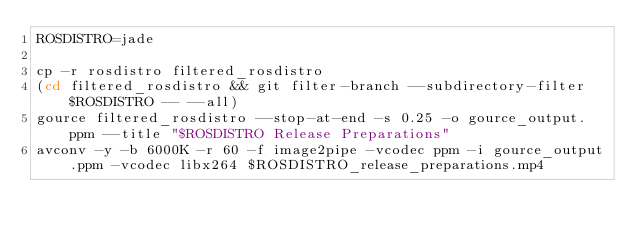<code> <loc_0><loc_0><loc_500><loc_500><_Bash_>ROSDISTRO=jade

cp -r rosdistro filtered_rosdistro
(cd filtered_rosdistro && git filter-branch --subdirectory-filter $ROSDISTRO -- --all)
gource filtered_rosdistro --stop-at-end -s 0.25 -o gource_output.ppm --title "$ROSDISTRO Release Preparations"
avconv -y -b 6000K -r 60 -f image2pipe -vcodec ppm -i gource_output.ppm -vcodec libx264 $ROSDISTRO_release_preparations.mp4
</code> 